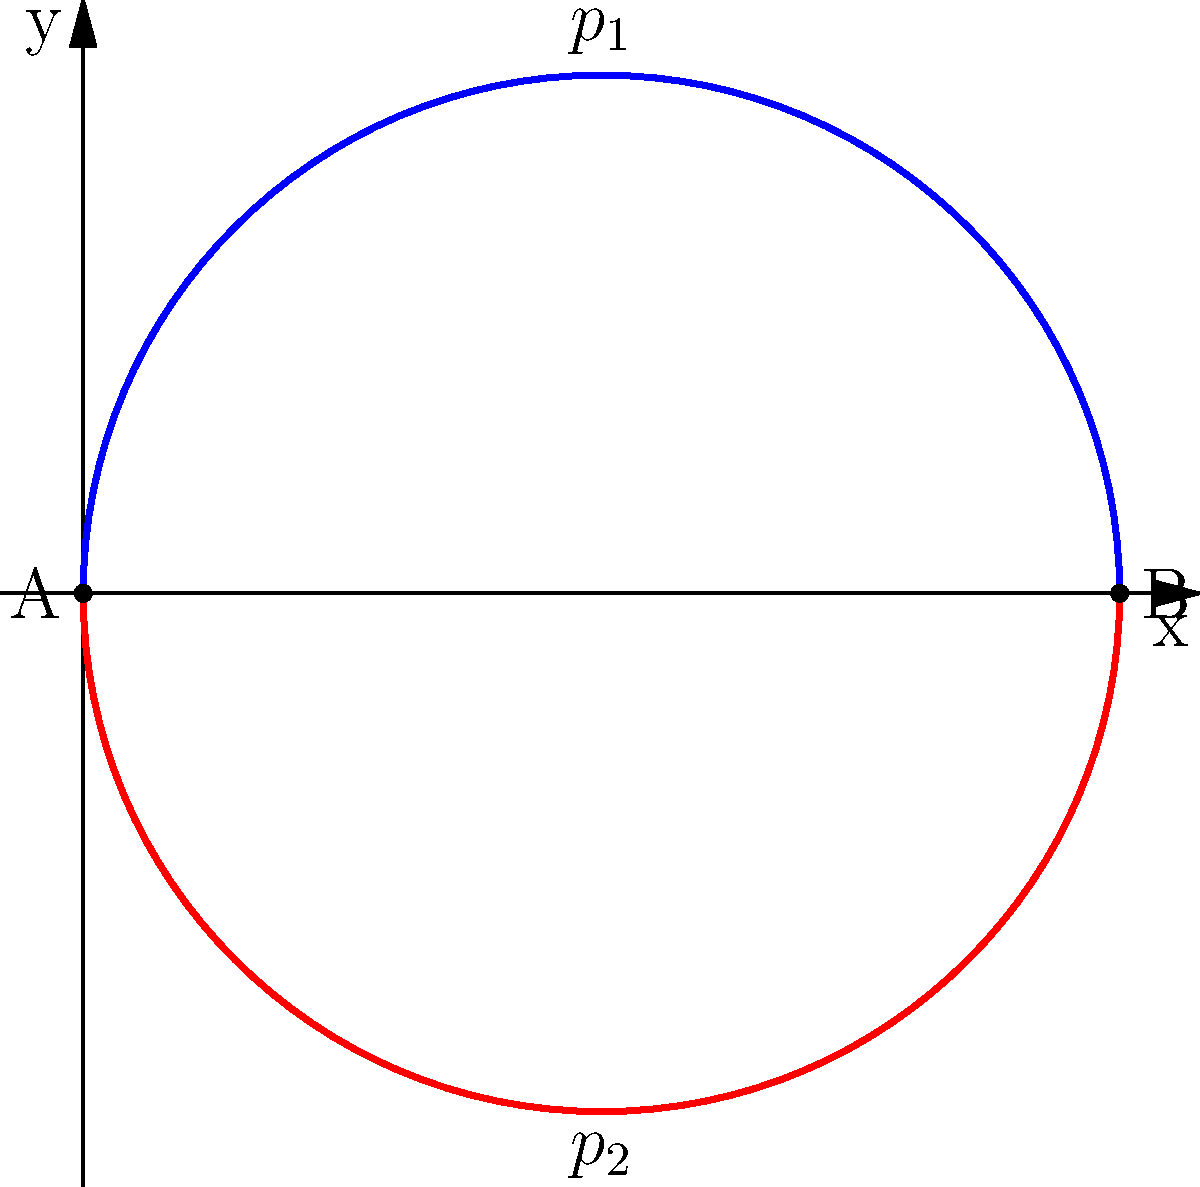Consider the two paths $p_1$ and $p_2$ in $\mathbb{R}^2$ shown in the figure, both connecting points A(0,0) and B(2,0). Using your knowledge of homotopy theory, determine if these paths are homotopic. If they are, briefly describe a homotopy between them. How might this concept be applied in the design of flight trajectories for aerospace vehicles? To determine if the paths $p_1$ and $p_2$ are homotopic, we need to follow these steps:

1. Understand the definition of homotopy: Two paths are homotopic if one can be continuously deformed into the other without leaving the space.

2. Analyze the space: The paths are in $\mathbb{R}^2$, which is a simply connected space.

3. Check for obstacles: There are no holes or obstacles between the paths.

4. Construct a homotopy: We can define a homotopy $H: [0,1] \times [0,1] \rightarrow \mathbb{R}^2$ as:

   $H(t,s) = (1-s)p_1(t) + sp_2(t)$

   Where $t$ parametrizes the paths and $s$ interpolates between them.

5. Verify the homotopy:
   - When $s=0$, $H(t,0) = p_1(t)$
   - When $s=1$, $H(t,1) = p_2(t)$
   - For $0 < s < 1$, $H(t,s)$ gives intermediate paths

6. Conclusion: The paths are homotopic because we can continuously deform one into the other.

Application to aerospace: This concept is crucial in trajectory planning for spacecraft or aircraft. It allows engineers to:
- Design flexible flight paths that can be adjusted in real-time
- Ensure smooth transitions between different trajectory options
- Optimize fuel consumption by finding equivalent paths
- Avoid obstacles or restricted airspace while maintaining the same start and end points
Answer: Yes, $p_1$ and $p_2$ are homotopic. A homotopy is $H(t,s) = (1-s)p_1(t) + sp_2(t)$. 